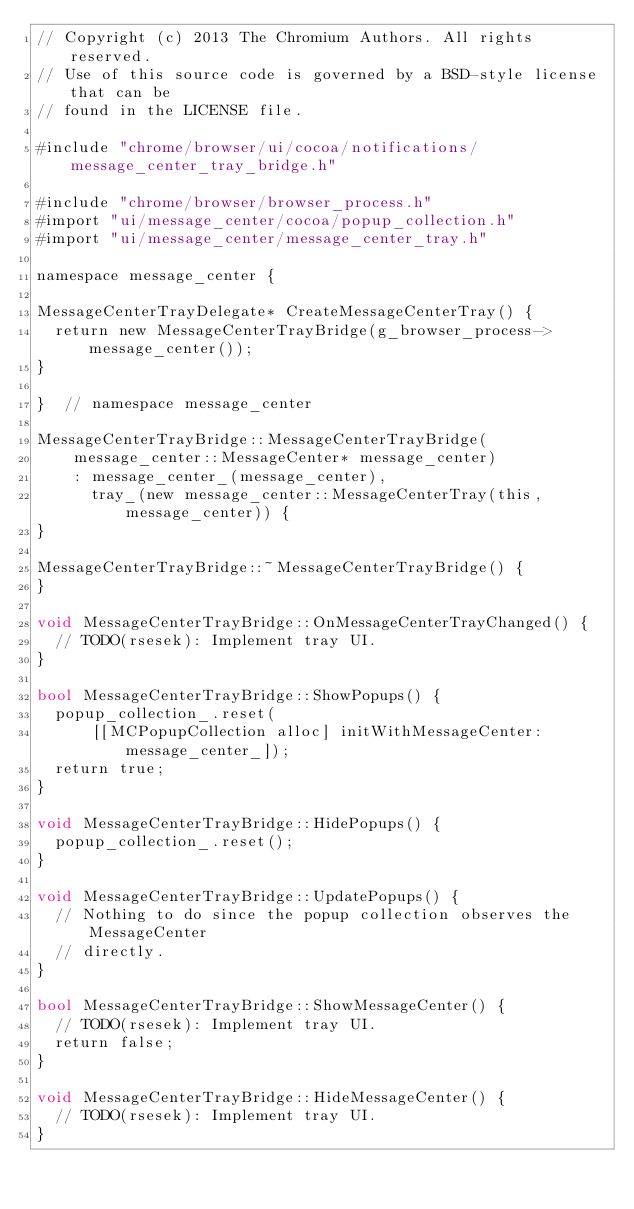Convert code to text. <code><loc_0><loc_0><loc_500><loc_500><_ObjectiveC_>// Copyright (c) 2013 The Chromium Authors. All rights reserved.
// Use of this source code is governed by a BSD-style license that can be
// found in the LICENSE file.

#include "chrome/browser/ui/cocoa/notifications/message_center_tray_bridge.h"

#include "chrome/browser/browser_process.h"
#import "ui/message_center/cocoa/popup_collection.h"
#import "ui/message_center/message_center_tray.h"

namespace message_center {

MessageCenterTrayDelegate* CreateMessageCenterTray() {
  return new MessageCenterTrayBridge(g_browser_process->message_center());
}

}  // namespace message_center

MessageCenterTrayBridge::MessageCenterTrayBridge(
    message_center::MessageCenter* message_center)
    : message_center_(message_center),
      tray_(new message_center::MessageCenterTray(this, message_center)) {
}

MessageCenterTrayBridge::~MessageCenterTrayBridge() {
}

void MessageCenterTrayBridge::OnMessageCenterTrayChanged() {
  // TODO(rsesek): Implement tray UI.
}

bool MessageCenterTrayBridge::ShowPopups() {
  popup_collection_.reset(
      [[MCPopupCollection alloc] initWithMessageCenter:message_center_]);
  return true;
}

void MessageCenterTrayBridge::HidePopups() {
  popup_collection_.reset();
}

void MessageCenterTrayBridge::UpdatePopups() {
  // Nothing to do since the popup collection observes the MessageCenter
  // directly.
}

bool MessageCenterTrayBridge::ShowMessageCenter() {
  // TODO(rsesek): Implement tray UI.
  return false;
}

void MessageCenterTrayBridge::HideMessageCenter() {
  // TODO(rsesek): Implement tray UI.
}
</code> 